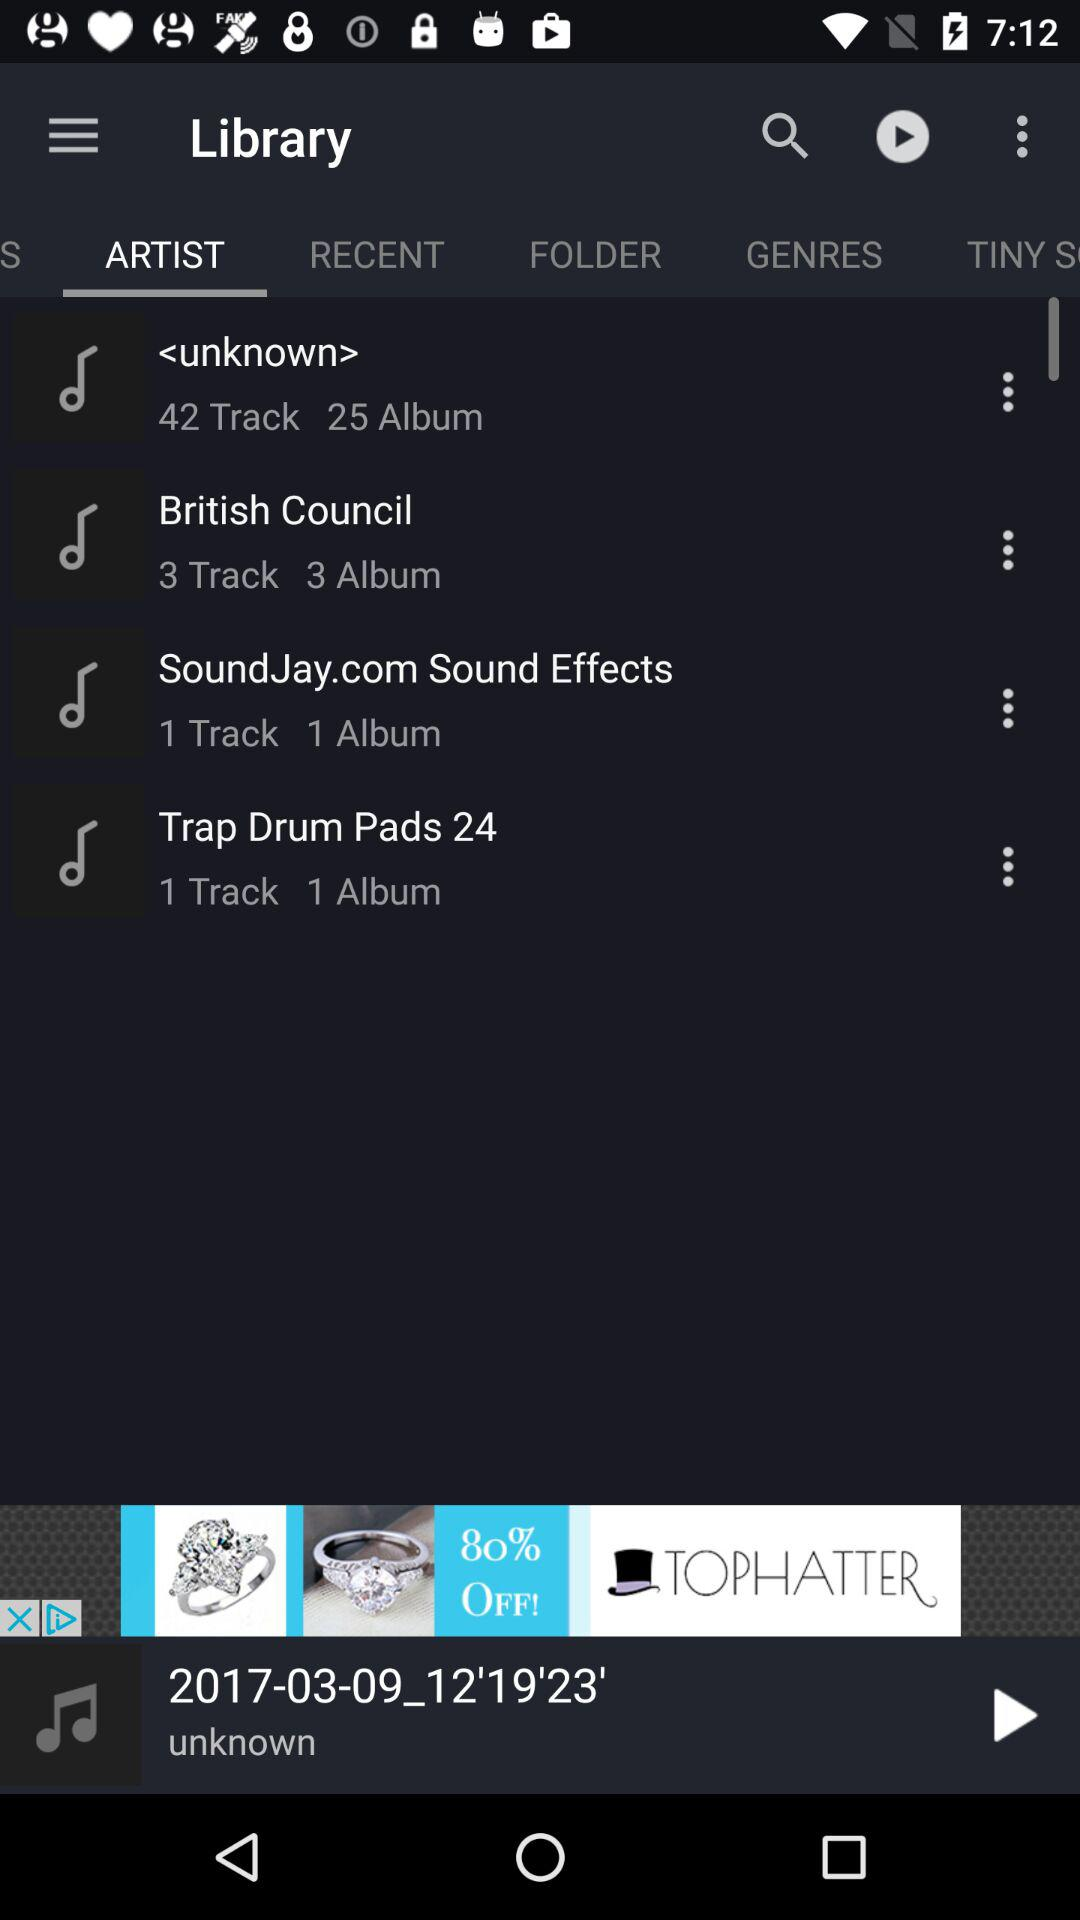How many more songs are in the British Council album than in the Trap Drum Pads album?
Answer the question using a single word or phrase. 2 